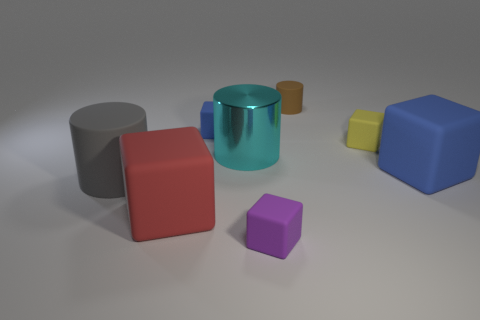Subtract all red cubes. How many cubes are left? 4 Subtract all large blue rubber cubes. How many cubes are left? 4 Subtract 1 blocks. How many blocks are left? 4 Subtract all green blocks. Subtract all red spheres. How many blocks are left? 5 Add 2 small blue rubber things. How many objects exist? 10 Subtract all cylinders. How many objects are left? 5 Add 3 big gray spheres. How many big gray spheres exist? 3 Subtract 0 brown balls. How many objects are left? 8 Subtract all big brown rubber blocks. Subtract all yellow cubes. How many objects are left? 7 Add 4 tiny objects. How many tiny objects are left? 8 